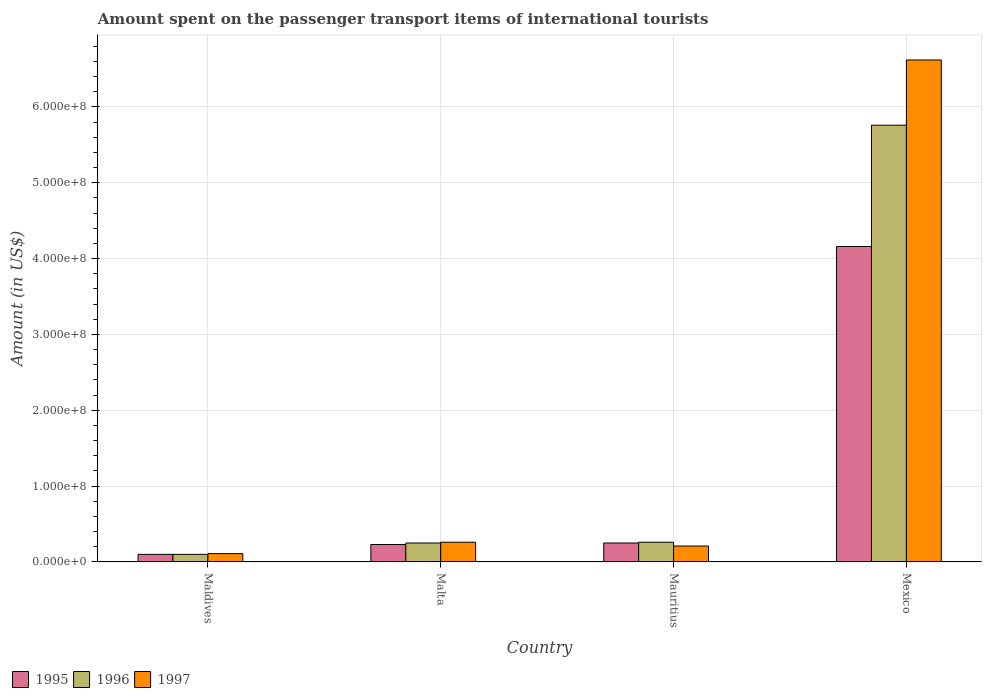How many different coloured bars are there?
Ensure brevity in your answer.  3. How many bars are there on the 3rd tick from the right?
Provide a succinct answer. 3. What is the label of the 4th group of bars from the left?
Ensure brevity in your answer.  Mexico. What is the amount spent on the passenger transport items of international tourists in 1995 in Maldives?
Give a very brief answer. 1.00e+07. Across all countries, what is the maximum amount spent on the passenger transport items of international tourists in 1995?
Keep it short and to the point. 4.16e+08. In which country was the amount spent on the passenger transport items of international tourists in 1995 maximum?
Offer a terse response. Mexico. In which country was the amount spent on the passenger transport items of international tourists in 1995 minimum?
Your answer should be compact. Maldives. What is the total amount spent on the passenger transport items of international tourists in 1995 in the graph?
Provide a short and direct response. 4.74e+08. What is the difference between the amount spent on the passenger transport items of international tourists in 1997 in Maldives and that in Mexico?
Provide a short and direct response. -6.51e+08. What is the difference between the amount spent on the passenger transport items of international tourists in 1997 in Malta and the amount spent on the passenger transport items of international tourists in 1995 in Mexico?
Provide a succinct answer. -3.90e+08. What is the average amount spent on the passenger transport items of international tourists in 1996 per country?
Provide a succinct answer. 1.59e+08. What is the difference between the amount spent on the passenger transport items of international tourists of/in 1996 and amount spent on the passenger transport items of international tourists of/in 1995 in Maldives?
Make the answer very short. 0. What is the ratio of the amount spent on the passenger transport items of international tourists in 1997 in Mauritius to that in Mexico?
Your answer should be very brief. 0.03. Is the amount spent on the passenger transport items of international tourists in 1997 in Mauritius less than that in Mexico?
Make the answer very short. Yes. What is the difference between the highest and the second highest amount spent on the passenger transport items of international tourists in 1997?
Offer a very short reply. 6.41e+08. What is the difference between the highest and the lowest amount spent on the passenger transport items of international tourists in 1997?
Keep it short and to the point. 6.51e+08. Is it the case that in every country, the sum of the amount spent on the passenger transport items of international tourists in 1996 and amount spent on the passenger transport items of international tourists in 1995 is greater than the amount spent on the passenger transport items of international tourists in 1997?
Provide a short and direct response. Yes. Are all the bars in the graph horizontal?
Your answer should be very brief. No. Are the values on the major ticks of Y-axis written in scientific E-notation?
Ensure brevity in your answer.  Yes. Where does the legend appear in the graph?
Offer a very short reply. Bottom left. How are the legend labels stacked?
Offer a terse response. Horizontal. What is the title of the graph?
Give a very brief answer. Amount spent on the passenger transport items of international tourists. What is the label or title of the Y-axis?
Provide a succinct answer. Amount (in US$). What is the Amount (in US$) of 1995 in Maldives?
Provide a short and direct response. 1.00e+07. What is the Amount (in US$) in 1997 in Maldives?
Keep it short and to the point. 1.10e+07. What is the Amount (in US$) in 1995 in Malta?
Give a very brief answer. 2.30e+07. What is the Amount (in US$) in 1996 in Malta?
Keep it short and to the point. 2.50e+07. What is the Amount (in US$) of 1997 in Malta?
Keep it short and to the point. 2.60e+07. What is the Amount (in US$) of 1995 in Mauritius?
Give a very brief answer. 2.50e+07. What is the Amount (in US$) in 1996 in Mauritius?
Your answer should be compact. 2.60e+07. What is the Amount (in US$) of 1997 in Mauritius?
Your response must be concise. 2.10e+07. What is the Amount (in US$) of 1995 in Mexico?
Keep it short and to the point. 4.16e+08. What is the Amount (in US$) in 1996 in Mexico?
Your response must be concise. 5.76e+08. What is the Amount (in US$) of 1997 in Mexico?
Ensure brevity in your answer.  6.62e+08. Across all countries, what is the maximum Amount (in US$) in 1995?
Make the answer very short. 4.16e+08. Across all countries, what is the maximum Amount (in US$) in 1996?
Give a very brief answer. 5.76e+08. Across all countries, what is the maximum Amount (in US$) of 1997?
Give a very brief answer. 6.62e+08. Across all countries, what is the minimum Amount (in US$) in 1995?
Keep it short and to the point. 1.00e+07. Across all countries, what is the minimum Amount (in US$) of 1997?
Keep it short and to the point. 1.10e+07. What is the total Amount (in US$) of 1995 in the graph?
Provide a short and direct response. 4.74e+08. What is the total Amount (in US$) of 1996 in the graph?
Keep it short and to the point. 6.37e+08. What is the total Amount (in US$) in 1997 in the graph?
Offer a very short reply. 7.20e+08. What is the difference between the Amount (in US$) of 1995 in Maldives and that in Malta?
Provide a succinct answer. -1.30e+07. What is the difference between the Amount (in US$) in 1996 in Maldives and that in Malta?
Your answer should be very brief. -1.50e+07. What is the difference between the Amount (in US$) in 1997 in Maldives and that in Malta?
Provide a short and direct response. -1.50e+07. What is the difference between the Amount (in US$) of 1995 in Maldives and that in Mauritius?
Keep it short and to the point. -1.50e+07. What is the difference between the Amount (in US$) in 1996 in Maldives and that in Mauritius?
Your answer should be compact. -1.60e+07. What is the difference between the Amount (in US$) in 1997 in Maldives and that in Mauritius?
Your answer should be very brief. -1.00e+07. What is the difference between the Amount (in US$) of 1995 in Maldives and that in Mexico?
Provide a short and direct response. -4.06e+08. What is the difference between the Amount (in US$) in 1996 in Maldives and that in Mexico?
Offer a terse response. -5.66e+08. What is the difference between the Amount (in US$) of 1997 in Maldives and that in Mexico?
Your answer should be very brief. -6.51e+08. What is the difference between the Amount (in US$) in 1995 in Malta and that in Mauritius?
Make the answer very short. -2.00e+06. What is the difference between the Amount (in US$) in 1995 in Malta and that in Mexico?
Your answer should be compact. -3.93e+08. What is the difference between the Amount (in US$) of 1996 in Malta and that in Mexico?
Your answer should be compact. -5.51e+08. What is the difference between the Amount (in US$) of 1997 in Malta and that in Mexico?
Provide a short and direct response. -6.36e+08. What is the difference between the Amount (in US$) in 1995 in Mauritius and that in Mexico?
Ensure brevity in your answer.  -3.91e+08. What is the difference between the Amount (in US$) of 1996 in Mauritius and that in Mexico?
Offer a terse response. -5.50e+08. What is the difference between the Amount (in US$) of 1997 in Mauritius and that in Mexico?
Your response must be concise. -6.41e+08. What is the difference between the Amount (in US$) of 1995 in Maldives and the Amount (in US$) of 1996 in Malta?
Ensure brevity in your answer.  -1.50e+07. What is the difference between the Amount (in US$) of 1995 in Maldives and the Amount (in US$) of 1997 in Malta?
Provide a succinct answer. -1.60e+07. What is the difference between the Amount (in US$) in 1996 in Maldives and the Amount (in US$) in 1997 in Malta?
Provide a short and direct response. -1.60e+07. What is the difference between the Amount (in US$) in 1995 in Maldives and the Amount (in US$) in 1996 in Mauritius?
Give a very brief answer. -1.60e+07. What is the difference between the Amount (in US$) in 1995 in Maldives and the Amount (in US$) in 1997 in Mauritius?
Give a very brief answer. -1.10e+07. What is the difference between the Amount (in US$) of 1996 in Maldives and the Amount (in US$) of 1997 in Mauritius?
Keep it short and to the point. -1.10e+07. What is the difference between the Amount (in US$) in 1995 in Maldives and the Amount (in US$) in 1996 in Mexico?
Offer a terse response. -5.66e+08. What is the difference between the Amount (in US$) in 1995 in Maldives and the Amount (in US$) in 1997 in Mexico?
Offer a very short reply. -6.52e+08. What is the difference between the Amount (in US$) of 1996 in Maldives and the Amount (in US$) of 1997 in Mexico?
Give a very brief answer. -6.52e+08. What is the difference between the Amount (in US$) in 1995 in Malta and the Amount (in US$) in 1996 in Mauritius?
Your answer should be very brief. -3.00e+06. What is the difference between the Amount (in US$) in 1995 in Malta and the Amount (in US$) in 1997 in Mauritius?
Make the answer very short. 2.00e+06. What is the difference between the Amount (in US$) of 1996 in Malta and the Amount (in US$) of 1997 in Mauritius?
Offer a terse response. 4.00e+06. What is the difference between the Amount (in US$) of 1995 in Malta and the Amount (in US$) of 1996 in Mexico?
Your answer should be compact. -5.53e+08. What is the difference between the Amount (in US$) of 1995 in Malta and the Amount (in US$) of 1997 in Mexico?
Provide a short and direct response. -6.39e+08. What is the difference between the Amount (in US$) in 1996 in Malta and the Amount (in US$) in 1997 in Mexico?
Offer a terse response. -6.37e+08. What is the difference between the Amount (in US$) of 1995 in Mauritius and the Amount (in US$) of 1996 in Mexico?
Your answer should be compact. -5.51e+08. What is the difference between the Amount (in US$) in 1995 in Mauritius and the Amount (in US$) in 1997 in Mexico?
Ensure brevity in your answer.  -6.37e+08. What is the difference between the Amount (in US$) of 1996 in Mauritius and the Amount (in US$) of 1997 in Mexico?
Give a very brief answer. -6.36e+08. What is the average Amount (in US$) of 1995 per country?
Your answer should be very brief. 1.18e+08. What is the average Amount (in US$) in 1996 per country?
Your answer should be compact. 1.59e+08. What is the average Amount (in US$) in 1997 per country?
Your response must be concise. 1.80e+08. What is the difference between the Amount (in US$) of 1996 and Amount (in US$) of 1997 in Maldives?
Your answer should be very brief. -1.00e+06. What is the difference between the Amount (in US$) in 1995 and Amount (in US$) in 1997 in Malta?
Make the answer very short. -3.00e+06. What is the difference between the Amount (in US$) in 1995 and Amount (in US$) in 1997 in Mauritius?
Ensure brevity in your answer.  4.00e+06. What is the difference between the Amount (in US$) in 1996 and Amount (in US$) in 1997 in Mauritius?
Provide a short and direct response. 5.00e+06. What is the difference between the Amount (in US$) of 1995 and Amount (in US$) of 1996 in Mexico?
Offer a very short reply. -1.60e+08. What is the difference between the Amount (in US$) in 1995 and Amount (in US$) in 1997 in Mexico?
Provide a short and direct response. -2.46e+08. What is the difference between the Amount (in US$) in 1996 and Amount (in US$) in 1997 in Mexico?
Your response must be concise. -8.60e+07. What is the ratio of the Amount (in US$) in 1995 in Maldives to that in Malta?
Provide a succinct answer. 0.43. What is the ratio of the Amount (in US$) in 1997 in Maldives to that in Malta?
Make the answer very short. 0.42. What is the ratio of the Amount (in US$) of 1996 in Maldives to that in Mauritius?
Your response must be concise. 0.38. What is the ratio of the Amount (in US$) of 1997 in Maldives to that in Mauritius?
Give a very brief answer. 0.52. What is the ratio of the Amount (in US$) of 1995 in Maldives to that in Mexico?
Make the answer very short. 0.02. What is the ratio of the Amount (in US$) in 1996 in Maldives to that in Mexico?
Ensure brevity in your answer.  0.02. What is the ratio of the Amount (in US$) of 1997 in Maldives to that in Mexico?
Your answer should be compact. 0.02. What is the ratio of the Amount (in US$) of 1996 in Malta to that in Mauritius?
Offer a very short reply. 0.96. What is the ratio of the Amount (in US$) in 1997 in Malta to that in Mauritius?
Keep it short and to the point. 1.24. What is the ratio of the Amount (in US$) of 1995 in Malta to that in Mexico?
Your response must be concise. 0.06. What is the ratio of the Amount (in US$) in 1996 in Malta to that in Mexico?
Offer a very short reply. 0.04. What is the ratio of the Amount (in US$) in 1997 in Malta to that in Mexico?
Provide a succinct answer. 0.04. What is the ratio of the Amount (in US$) in 1995 in Mauritius to that in Mexico?
Provide a succinct answer. 0.06. What is the ratio of the Amount (in US$) in 1996 in Mauritius to that in Mexico?
Provide a succinct answer. 0.05. What is the ratio of the Amount (in US$) in 1997 in Mauritius to that in Mexico?
Your answer should be very brief. 0.03. What is the difference between the highest and the second highest Amount (in US$) in 1995?
Your answer should be very brief. 3.91e+08. What is the difference between the highest and the second highest Amount (in US$) in 1996?
Your answer should be compact. 5.50e+08. What is the difference between the highest and the second highest Amount (in US$) of 1997?
Make the answer very short. 6.36e+08. What is the difference between the highest and the lowest Amount (in US$) of 1995?
Offer a terse response. 4.06e+08. What is the difference between the highest and the lowest Amount (in US$) in 1996?
Keep it short and to the point. 5.66e+08. What is the difference between the highest and the lowest Amount (in US$) in 1997?
Offer a terse response. 6.51e+08. 